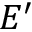<formula> <loc_0><loc_0><loc_500><loc_500>E ^ { \prime }</formula> 